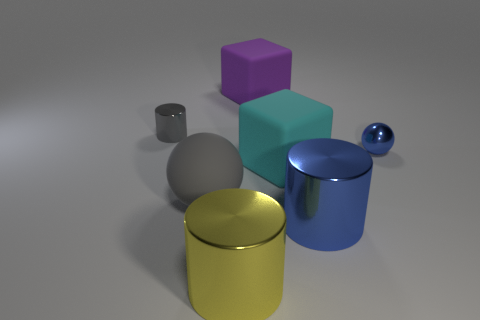There is a object that is both to the left of the big yellow cylinder and in front of the tiny blue metal ball; what is its shape?
Your response must be concise. Sphere. Is the large cube behind the gray cylinder made of the same material as the cyan thing?
Give a very brief answer. Yes. What color is the matte ball that is the same size as the yellow thing?
Offer a terse response. Gray. Are there any large metallic things of the same color as the shiny ball?
Your response must be concise. Yes. The gray cylinder that is made of the same material as the big blue object is what size?
Make the answer very short. Small. There is a metallic thing that is the same color as the big ball; what size is it?
Make the answer very short. Small. What number of other things are there of the same size as the yellow shiny thing?
Keep it short and to the point. 4. What material is the cylinder in front of the blue shiny cylinder?
Your response must be concise. Metal. The large blue object on the right side of the large thing that is in front of the blue metal thing in front of the gray matte thing is what shape?
Offer a very short reply. Cylinder. Does the purple rubber block have the same size as the gray cylinder?
Provide a short and direct response. No. 